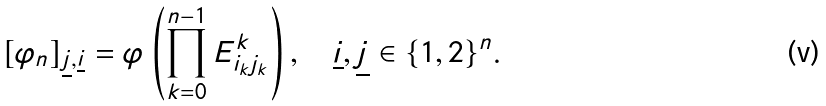Convert formula to latex. <formula><loc_0><loc_0><loc_500><loc_500>[ \varphi _ { n } ] _ { \underline { j } , \underline { i } } = \varphi \left ( \prod _ { k = 0 } ^ { n - 1 } E _ { i _ { k } j _ { k } } ^ { k } \right ) , \quad \underline { i } , \underline { j } \in \{ 1 , 2 \} ^ { n } .</formula> 